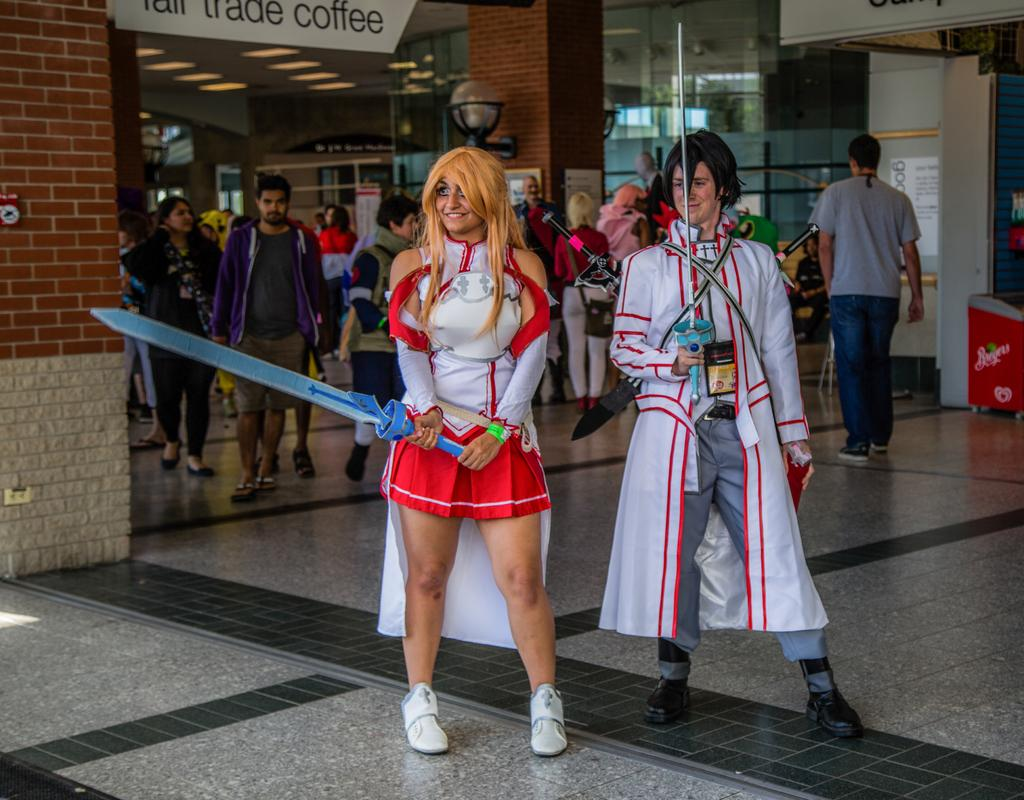<image>
Write a terse but informative summary of the picture. A woman swinging a toy sword in front of a Tall Trade Coffee store. 